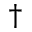<formula> <loc_0><loc_0><loc_500><loc_500>^ { \dagger }</formula> 